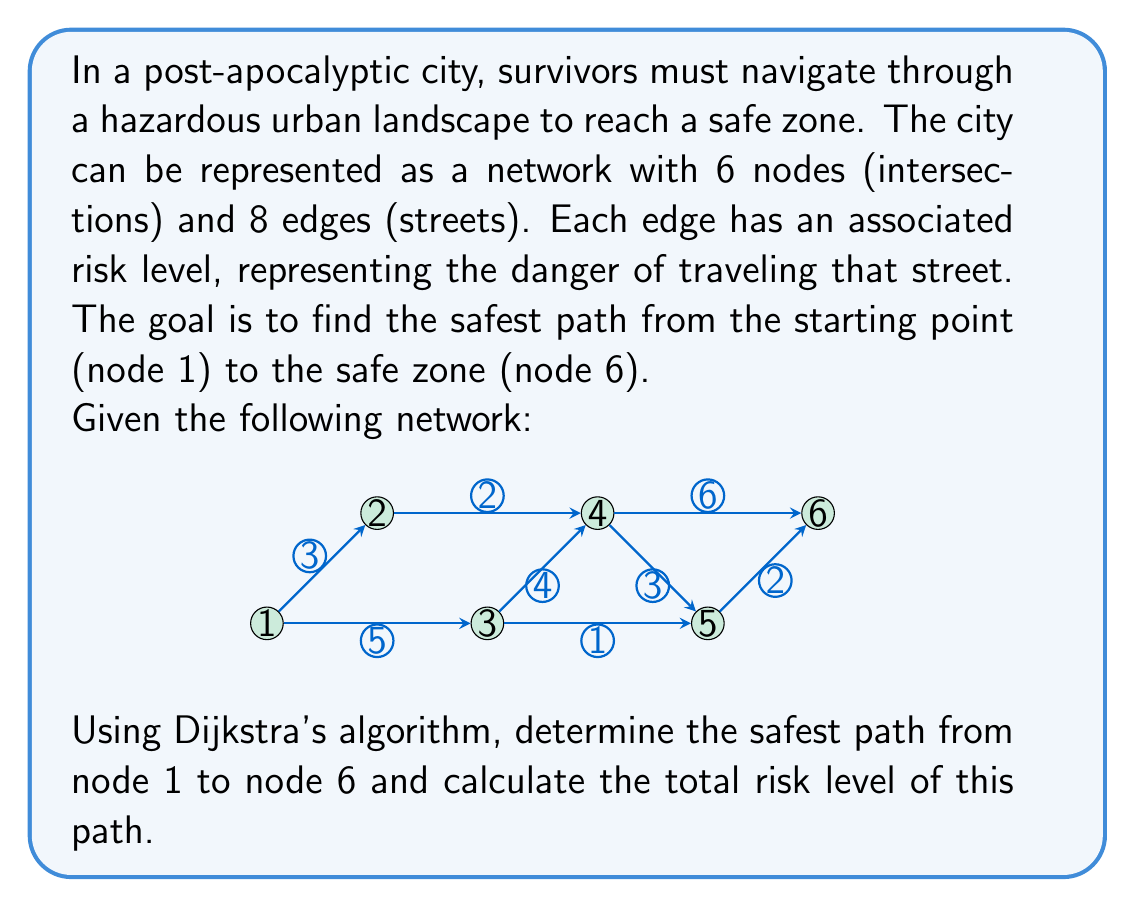Can you solve this math problem? To solve this problem, we'll use Dijkstra's algorithm to find the shortest path, where "shortest" in this context means the path with the lowest total risk level. Here's a step-by-step explanation:

1. Initialize:
   - Set the distance to the starting node (1) as 0.
   - Set the distance to all other nodes as infinity.
   - Create a set of unvisited nodes containing all nodes.

2. For the current node (starting with node 1), consider all its unvisited neighbors and calculate their tentative distances.
   - Compare the newly calculated tentative distance to the current assigned value and assign the smaller one.

3. When we're done considering all neighbors of the current node, mark it as visited and remove it from the unvisited set.

4. If the destination node (6) has been marked visited, we're done. Otherwise, select the unvisited node with the smallest tentative distance and set it as the new current node. Go back to step 2.

Let's apply the algorithm:

Iteration 1 (Node 1):
- Update Node 2: min(∞, 0 + 3) = 3
- Update Node 3: min(∞, 0 + 5) = 5
- Mark Node 1 as visited

Iteration 2 (Node 2):
- Update Node 4: min(∞, 3 + 2) = 5
- Mark Node 2 as visited

Iteration 3 (Node 3):
- Update Node 4: min(5, 5 + 4) = 5 (no change)
- Update Node 5: min(∞, 5 + 1) = 6
- Mark Node 3 as visited

Iteration 4 (Node 4):
- Update Node 5: min(6, 5 + 3) = 6 (no change)
- Update Node 6: min(∞, 5 + 6) = 11
- Mark Node 4 as visited

Iteration 5 (Node 5):
- Update Node 6: min(11, 6 + 2) = 8
- Mark Node 5 as visited

Iteration 6 (Node 6):
- Mark Node 6 as visited

The algorithm terminates as we've reached the destination node.

The safest path from Node 1 to Node 6 is: 1 → 2 → 4 → 5 → 6

The total risk level of this path is: 3 + 2 + 3 + 2 = 10
Answer: The safest path from Node 1 to Node 6 is: 1 → 2 → 4 → 5 → 6, with a total risk level of 10. 